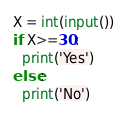Convert code to text. <code><loc_0><loc_0><loc_500><loc_500><_Python_>X = int(input())
if X>=30:
  print('Yes')
else:
  print('No')</code> 